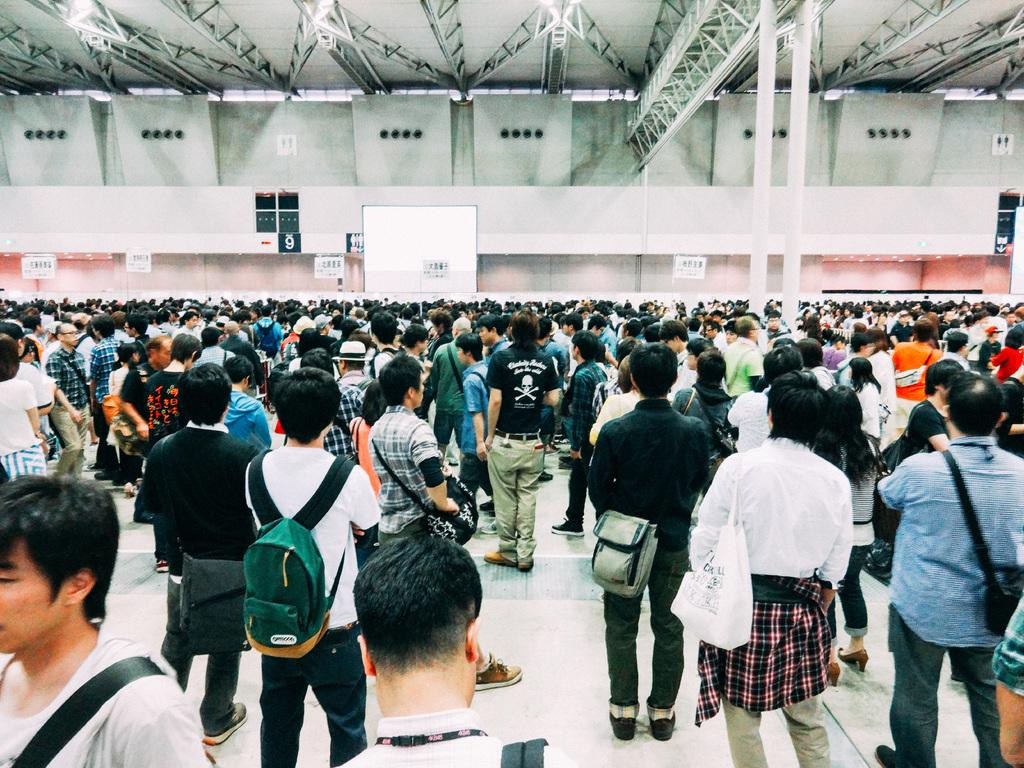How many people are in the image? There is a group of people in the image. What are the people in the image doing? The people are standing. Can you describe any accessories worn by the people? Two of the people are wearing bags. What can be seen on the wall in the image? There is a poster on a wall in the image. What other object related to presentations or discussions is visible in the image? There is a whiteboard in the image. What type of scarf is draped over the chairs in the image? There are no chairs or scarves present in the image. What impulse might have caused the people to gather in the image? The image does not provide information about the reason for the gathering, so it is impossible to determine the impulse that brought them together. 